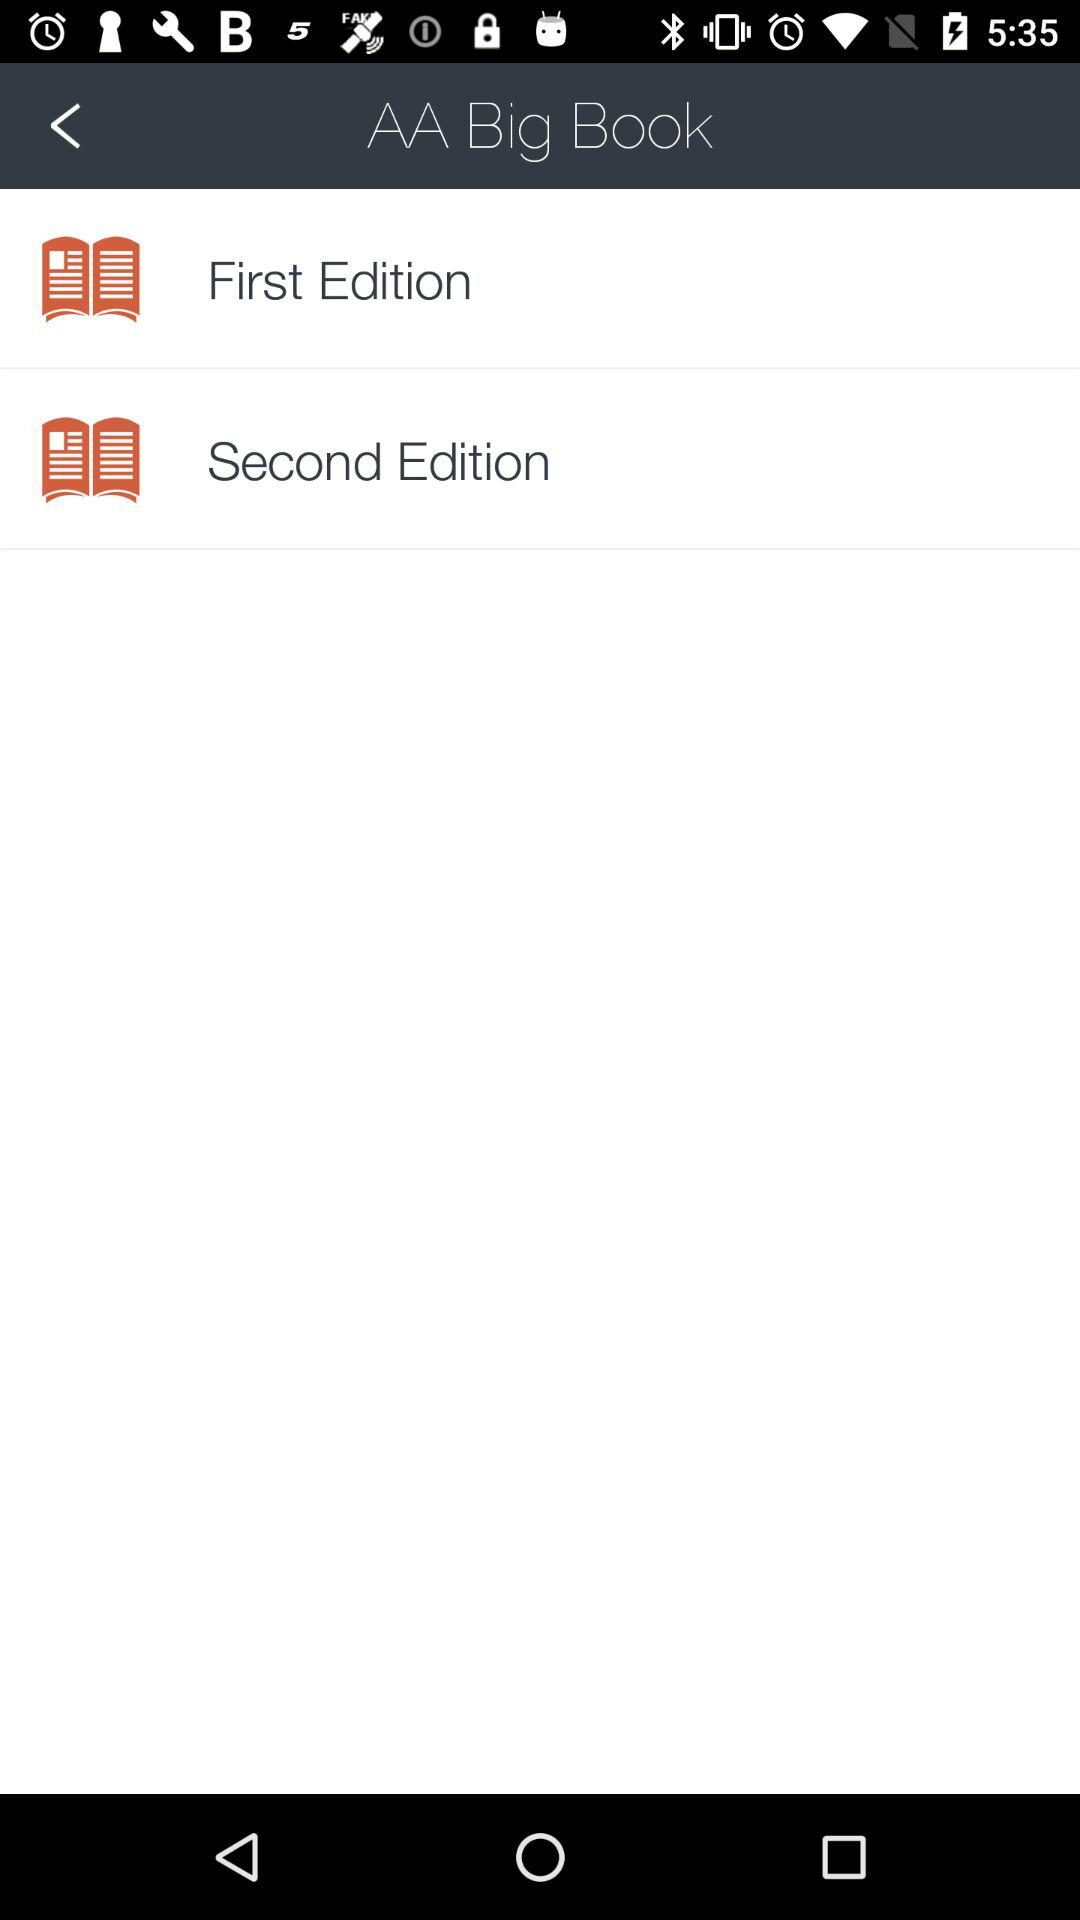What is the application name? The application name is "AA Big Book". 